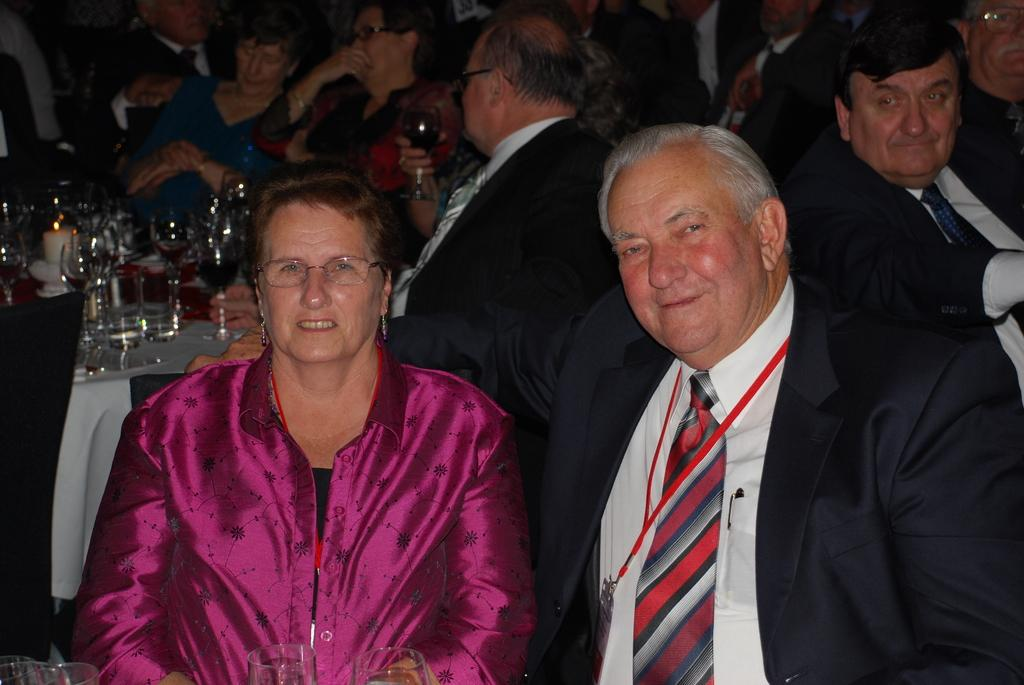What are the people in the image doing? The people in the image are sitting in front of a table. What can be seen on the table? There are glasses on the table. Are there any other objects on the table besides the glasses? Yes, there are other objects on the table. What type of rhythm can be heard coming from the trains in the image? There are no trains present in the image, so it is not possible to determine what type of rhythm might be heard. 